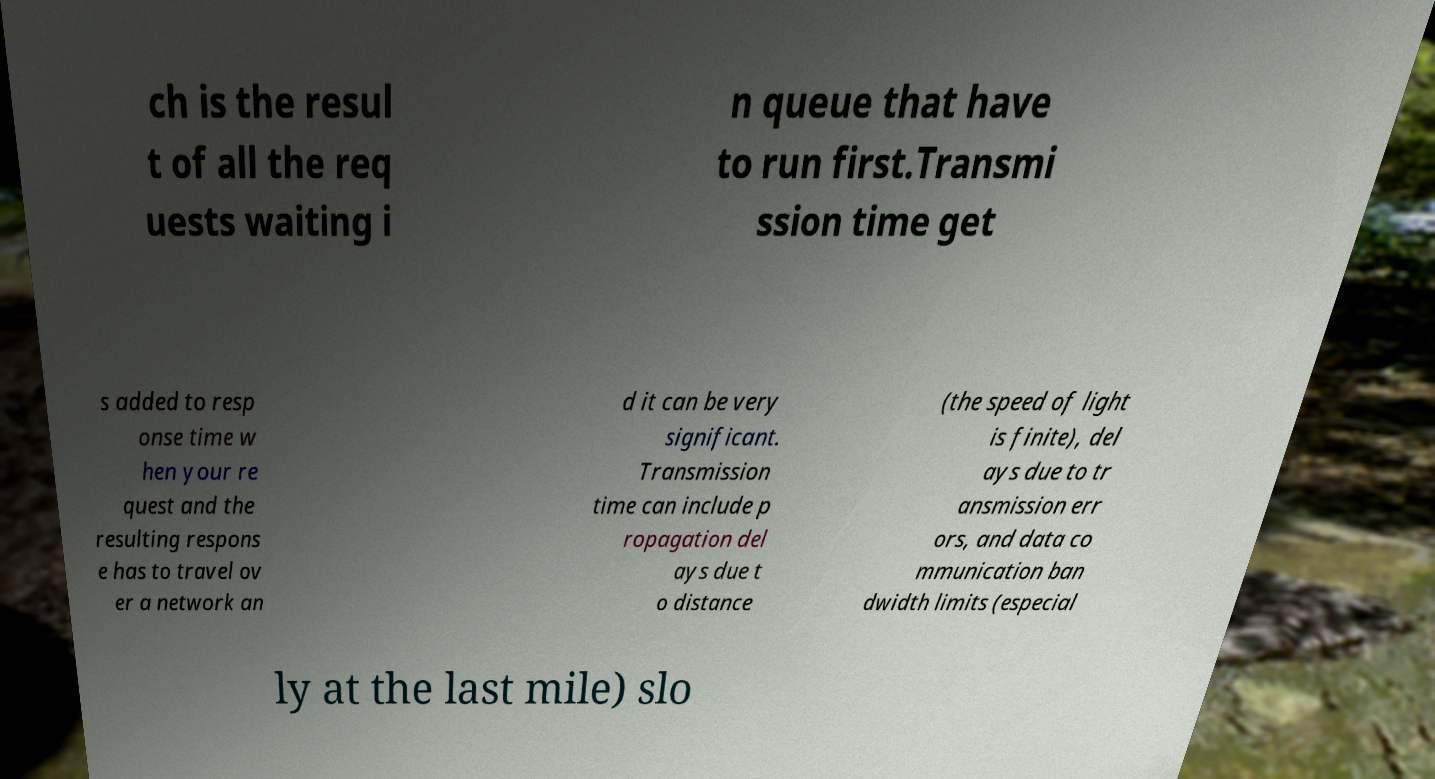Please read and relay the text visible in this image. What does it say? ch is the resul t of all the req uests waiting i n queue that have to run first.Transmi ssion time get s added to resp onse time w hen your re quest and the resulting respons e has to travel ov er a network an d it can be very significant. Transmission time can include p ropagation del ays due t o distance (the speed of light is finite), del ays due to tr ansmission err ors, and data co mmunication ban dwidth limits (especial ly at the last mile) slo 